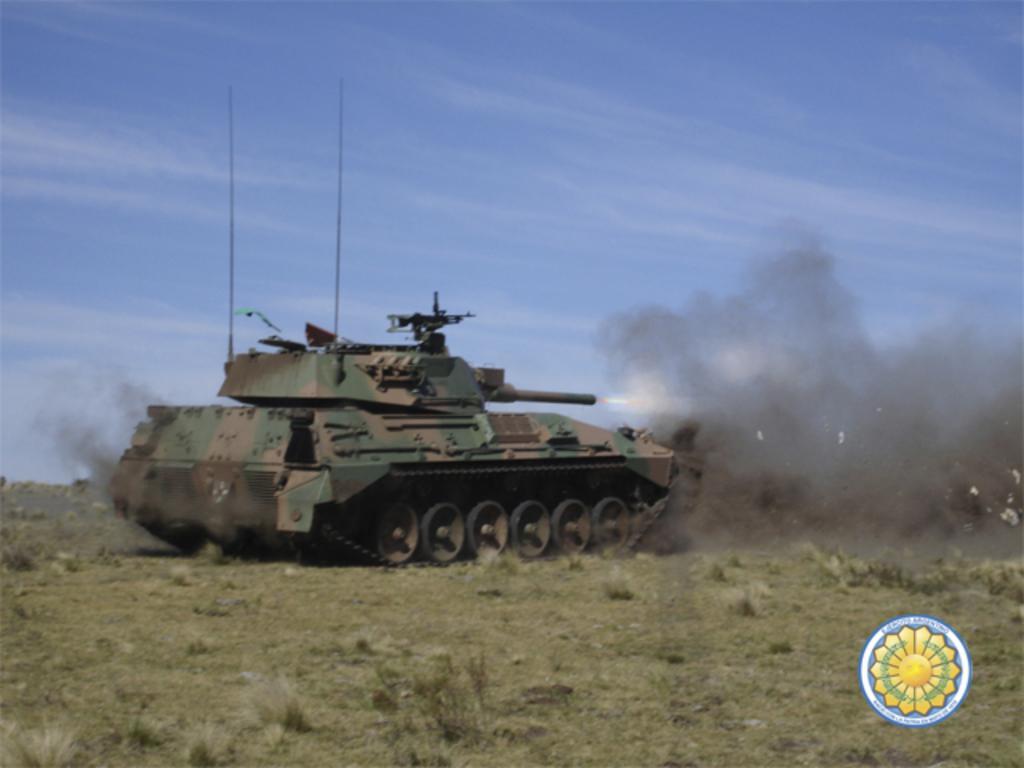Describe this image in one or two sentences. In this image there is a tank on the grass, and in the background there is sky and a watermark on the image. 